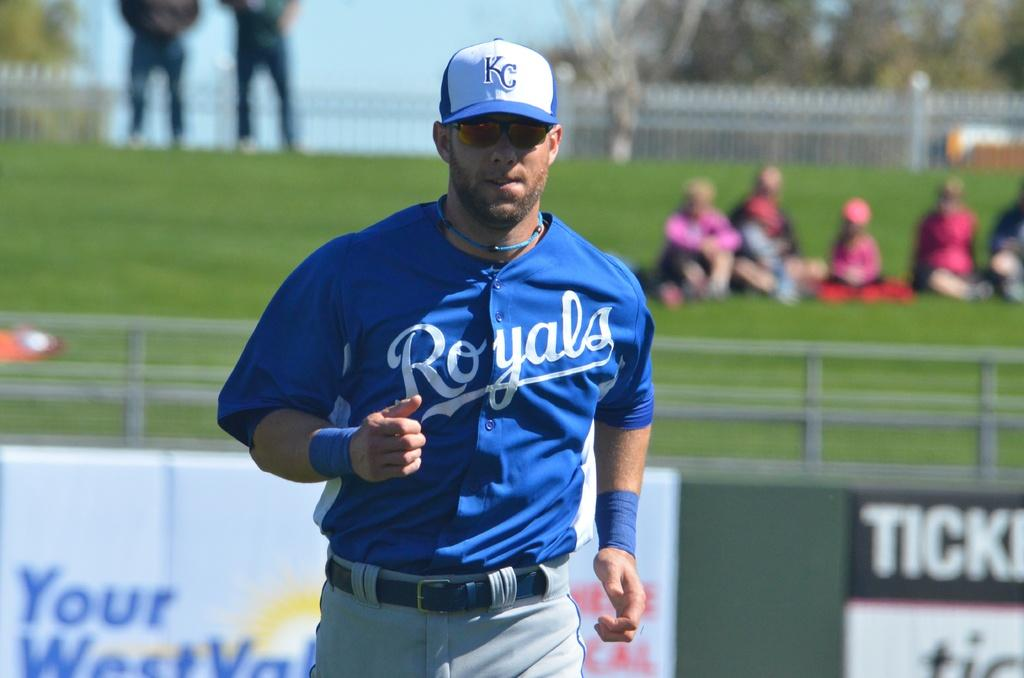<image>
Describe the image concisely. A baseball player is wearing a blue and gray royals uniform. 